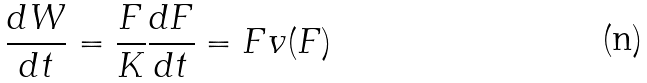<formula> <loc_0><loc_0><loc_500><loc_500>\frac { d W } { d t } = \frac { F } { K } \frac { d F } { d t } = F v ( F )</formula> 